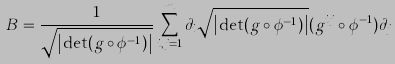Convert formula to latex. <formula><loc_0><loc_0><loc_500><loc_500>B = \frac { 1 } { \sqrt { \left | \det ( g \circ \phi ^ { - 1 } ) \right | } } \sum _ { i , j = 1 } ^ { m } \partial _ { i } { \sqrt { \left | \det ( g \circ \phi ^ { - 1 } ) \right | } } ( g ^ { i j } \circ \phi ^ { - 1 } ) \partial _ { j }</formula> 